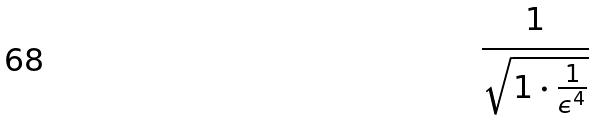<formula> <loc_0><loc_0><loc_500><loc_500>\frac { 1 } { \sqrt { 1 \cdot \frac { 1 } { \epsilon ^ { 4 } } } }</formula> 